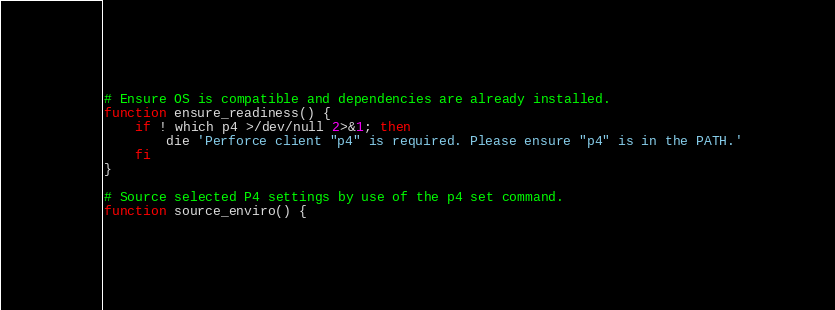<code> <loc_0><loc_0><loc_500><loc_500><_Bash_>
# Ensure OS is compatible and dependencies are already installed.
function ensure_readiness() {
    if ! which p4 >/dev/null 2>&1; then
        die 'Perforce client "p4" is required. Please ensure "p4" is in the PATH.'
    fi
}

# Source selected P4 settings by use of the p4 set command.
function source_enviro() {</code> 